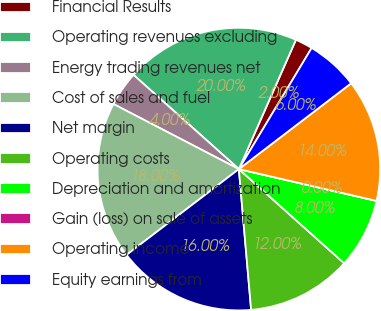<chart> <loc_0><loc_0><loc_500><loc_500><pie_chart><fcel>Financial Results<fcel>Operating revenues excluding<fcel>Energy trading revenues net<fcel>Cost of sales and fuel<fcel>Net margin<fcel>Operating costs<fcel>Depreciation and amortization<fcel>Gain (loss) on sale of assets<fcel>Operating income<fcel>Equity earnings from<nl><fcel>2.0%<fcel>20.0%<fcel>4.0%<fcel>18.0%<fcel>16.0%<fcel>12.0%<fcel>8.0%<fcel>0.0%<fcel>14.0%<fcel>6.0%<nl></chart> 